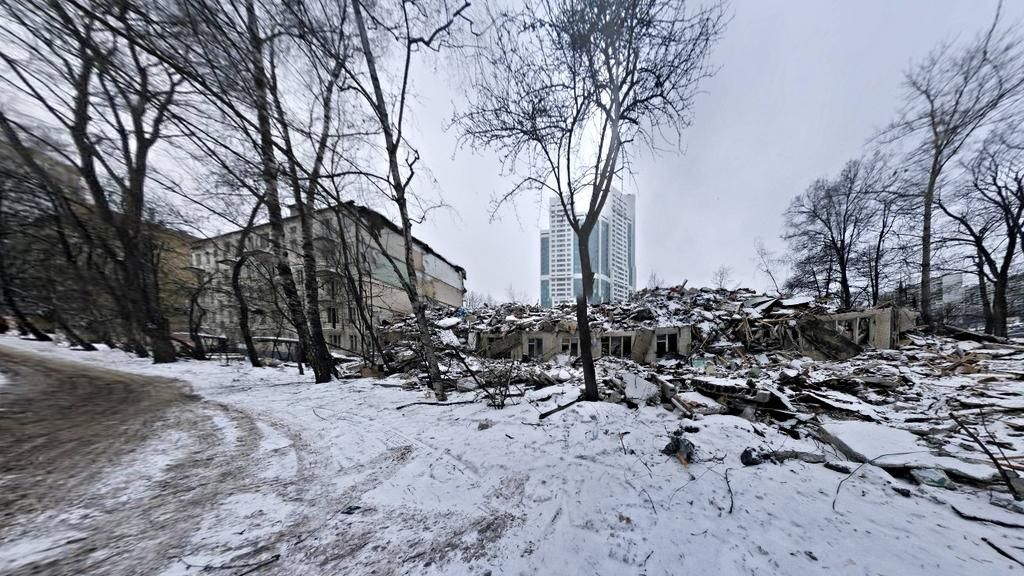What is covering the ground in the image? There is snow on the ground in the image. What type of natural elements can be seen in the image? There are trees in the image. What is the condition of the building in the image? There is a collapsed building in the image. What architectural features are visible in the image? There are windows visible in the image. What can be seen in the background of the image? There are buildings, trees, windows, and the sky visible in the background of the image. What type of nation is depicted in the image? There is no nation depicted in the image; it shows a collapsed building, snow, trees, and other elements. What is the tongue doing in the image? There is no tongue present in the image. 